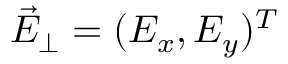<formula> <loc_0><loc_0><loc_500><loc_500>\vec { E } _ { \perp } = ( E _ { x } , E _ { y } ) ^ { T }</formula> 